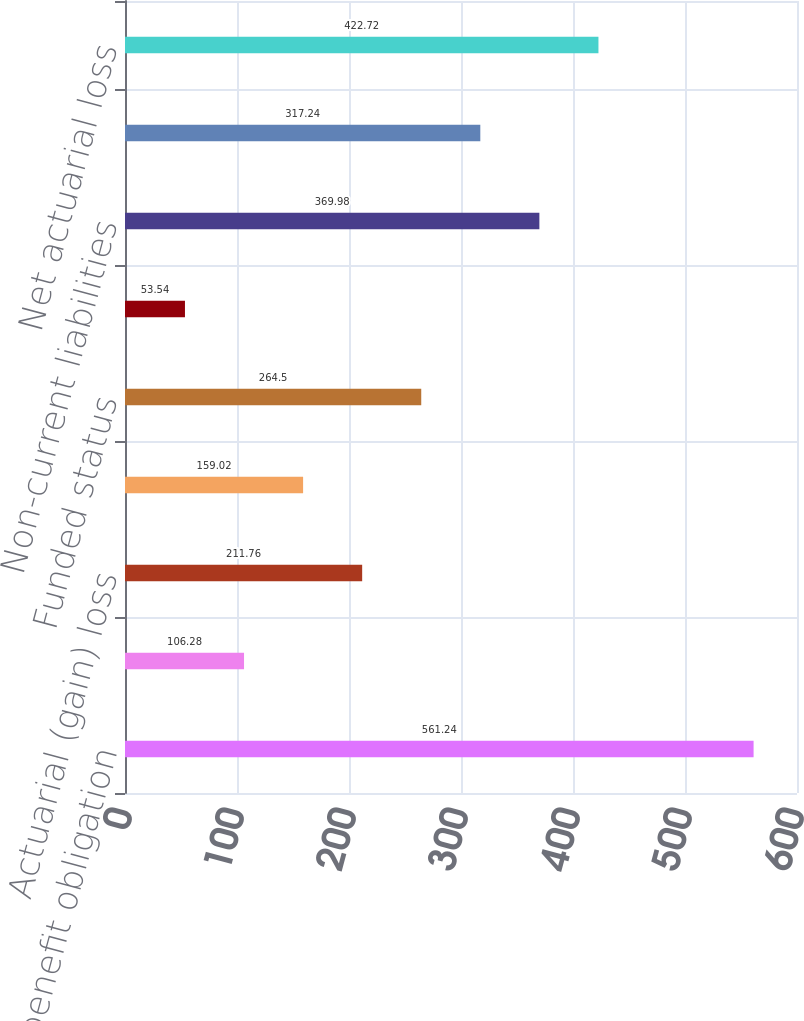<chart> <loc_0><loc_0><loc_500><loc_500><bar_chart><fcel>Projected benefit obligation<fcel>Interest cost<fcel>Actuarial (gain) loss<fcel>Benefits paid<fcel>Funded status<fcel>Current liabilities<fcel>Non-current liabilities<fcel>Net amount<fcel>Net actuarial loss<nl><fcel>561.24<fcel>106.28<fcel>211.76<fcel>159.02<fcel>264.5<fcel>53.54<fcel>369.98<fcel>317.24<fcel>422.72<nl></chart> 